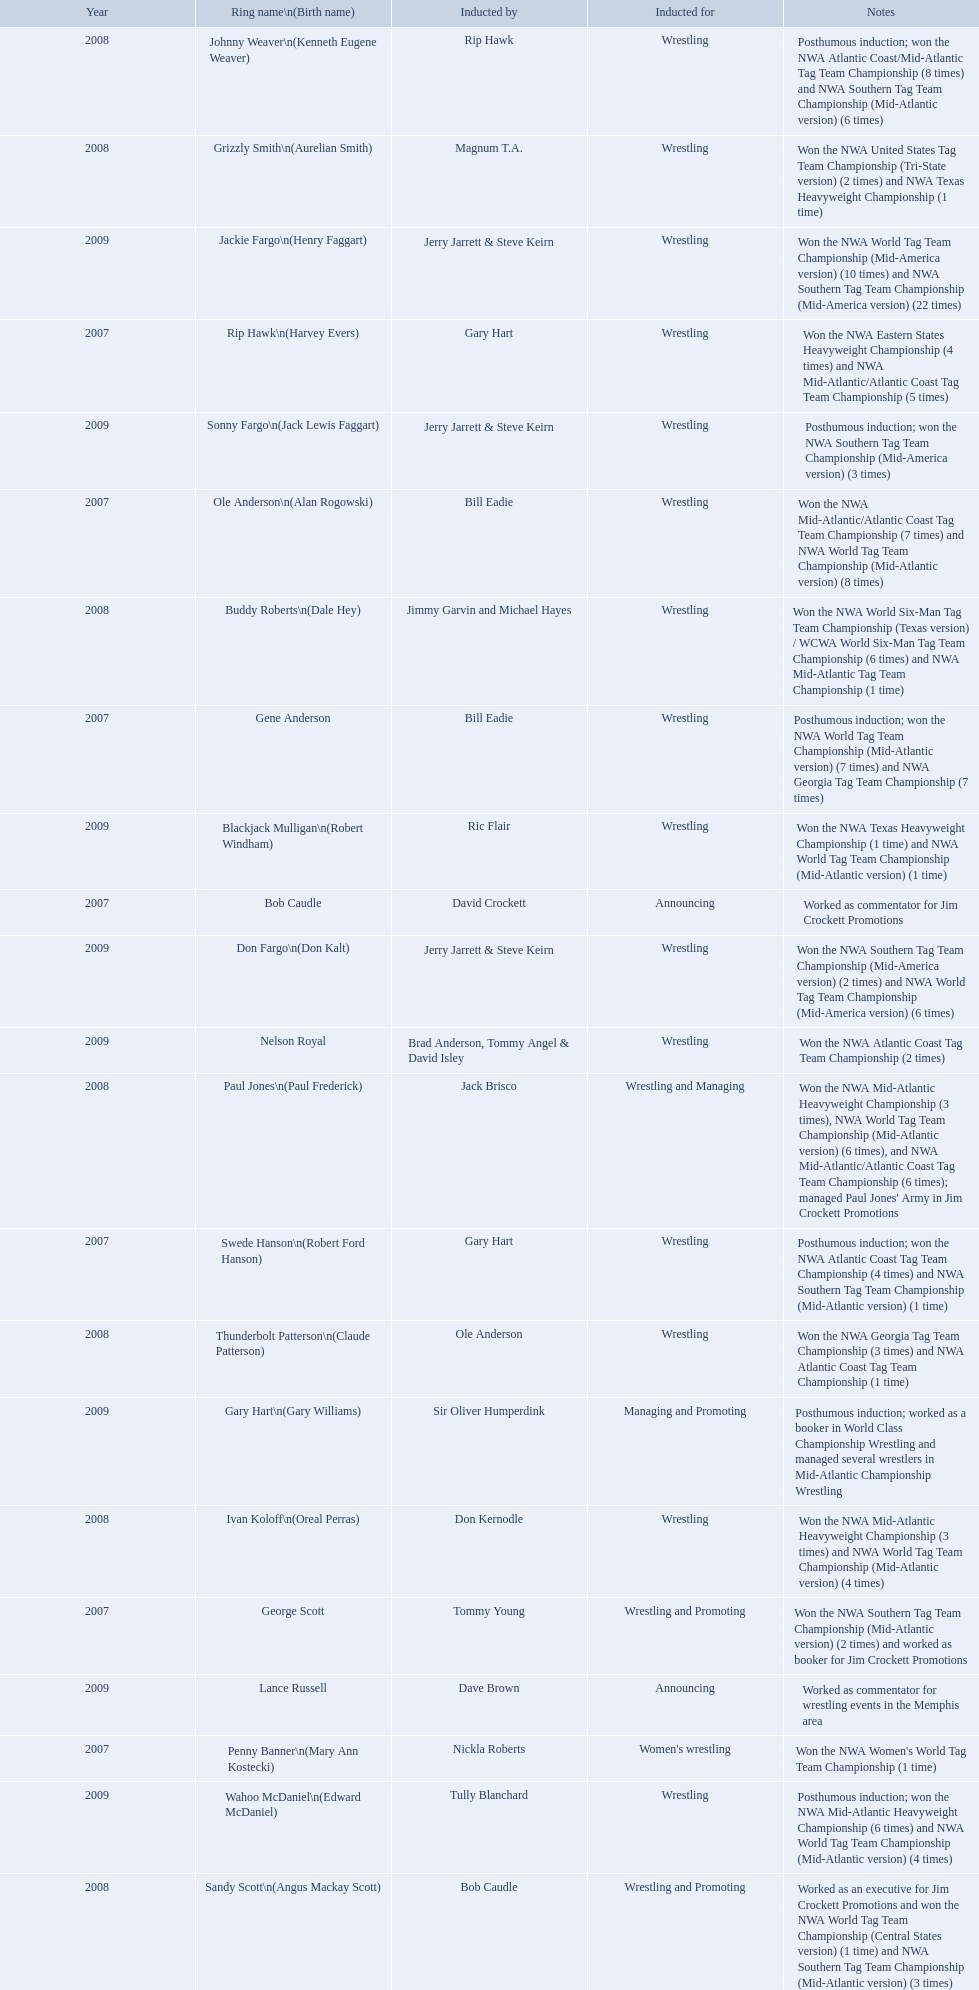What were the names of the inductees in 2007? Gene Anderson, Ole Anderson\n(Alan Rogowski), Penny Banner\n(Mary Ann Kostecki), Bob Caudle, Swede Hanson\n(Robert Ford Hanson), Rip Hawk\n(Harvey Evers), George Scott. Of the 2007 inductees, which were posthumous? Gene Anderson, Swede Hanson\n(Robert Ford Hanson). Besides swede hanson, what other 2007 inductee was not living at the time of induction? Gene Anderson. What announcers were inducted? Bob Caudle, Lance Russell. What announcer was inducted in 2009? Lance Russell. 